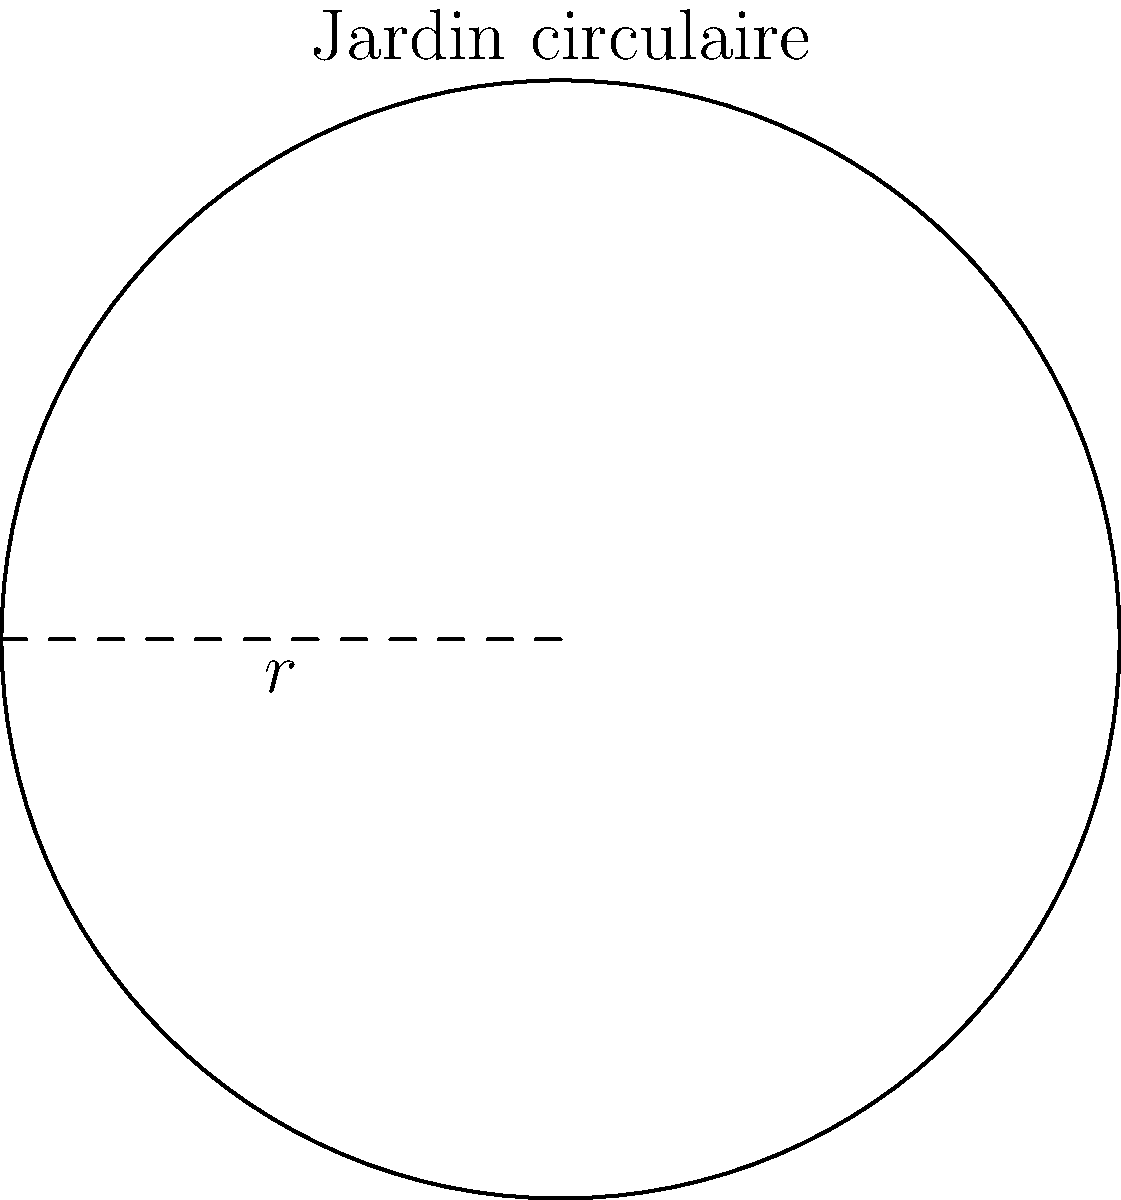Un jardin circulaire dans un parc public a un rayon de 15 mètres. La municipalité souhaite installer une clôture décorative autour du jardin. Calculez la longueur totale de la clôture nécessaire, arrondie au centimètre le plus proche, en tenant compte des réglementations locales qui exigent une marge de sécurité de 5% pour les espaces publics. Pour résoudre ce problème, suivons ces étapes :

1) La formule pour calculer le périmètre d'un cercle est :
   $$P = 2\pi r$$
   où $P$ est le périmètre et $r$ est le rayon.

2) Substituons le rayon donné (15 mètres) dans la formule :
   $$P = 2\pi (15) = 30\pi$$

3) Calculons cette valeur :
   $$30\pi \approx 94,2477796 \text{ mètres}$$

4) Les réglementations locales exigent une marge de sécurité de 5%. Calculons cette marge :
   $$94,2477796 \times 0,05 = 4,7123889 \text{ mètres}$$

5) Ajoutons cette marge à la longueur initiale :
   $$94,2477796 + 4,7123889 = 98,9601685 \text{ mètres}$$

6) Arrondissons au centimètre le plus proche :
   $$98,9601685 \text{ mètres} \approx 98,96 \text{ mètres}$$

Donc, la longueur totale de la clôture nécessaire, en tenant compte de la marge de sécurité et arrondie au centimètre le plus proche, est de 98,96 mètres.
Answer: 98,96 mètres 